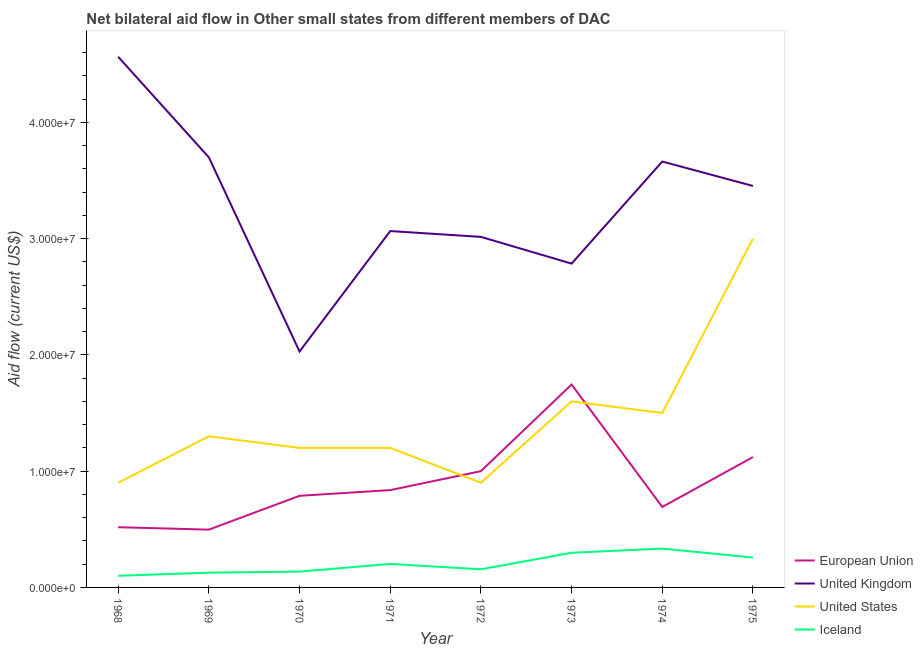How many different coloured lines are there?
Your answer should be very brief. 4. Is the number of lines equal to the number of legend labels?
Give a very brief answer. Yes. What is the amount of aid given by iceland in 1974?
Keep it short and to the point. 3.34e+06. Across all years, what is the maximum amount of aid given by uk?
Give a very brief answer. 4.56e+07. Across all years, what is the minimum amount of aid given by us?
Your answer should be very brief. 9.00e+06. In which year was the amount of aid given by us maximum?
Your response must be concise. 1975. In which year was the amount of aid given by us minimum?
Provide a succinct answer. 1968. What is the total amount of aid given by eu in the graph?
Provide a short and direct response. 7.20e+07. What is the difference between the amount of aid given by iceland in 1969 and that in 1971?
Provide a succinct answer. -7.50e+05. What is the difference between the amount of aid given by us in 1969 and the amount of aid given by uk in 1972?
Your answer should be very brief. -1.72e+07. What is the average amount of aid given by us per year?
Offer a terse response. 1.45e+07. In the year 1974, what is the difference between the amount of aid given by us and amount of aid given by uk?
Your answer should be compact. -2.16e+07. What is the ratio of the amount of aid given by uk in 1970 to that in 1972?
Provide a short and direct response. 0.67. Is the amount of aid given by us in 1970 less than that in 1972?
Provide a succinct answer. No. Is the difference between the amount of aid given by eu in 1970 and 1974 greater than the difference between the amount of aid given by us in 1970 and 1974?
Provide a short and direct response. Yes. What is the difference between the highest and the second highest amount of aid given by uk?
Give a very brief answer. 8.65e+06. What is the difference between the highest and the lowest amount of aid given by uk?
Your answer should be compact. 2.54e+07. Is it the case that in every year, the sum of the amount of aid given by eu and amount of aid given by uk is greater than the amount of aid given by us?
Your response must be concise. Yes. Is the amount of aid given by iceland strictly less than the amount of aid given by uk over the years?
Your answer should be compact. Yes. How many years are there in the graph?
Give a very brief answer. 8. What is the difference between two consecutive major ticks on the Y-axis?
Give a very brief answer. 1.00e+07. Are the values on the major ticks of Y-axis written in scientific E-notation?
Your response must be concise. Yes. Does the graph contain any zero values?
Keep it short and to the point. No. Where does the legend appear in the graph?
Your answer should be very brief. Bottom right. How many legend labels are there?
Offer a terse response. 4. What is the title of the graph?
Keep it short and to the point. Net bilateral aid flow in Other small states from different members of DAC. Does "Secondary general" appear as one of the legend labels in the graph?
Your response must be concise. No. What is the label or title of the X-axis?
Your response must be concise. Year. What is the label or title of the Y-axis?
Provide a succinct answer. Aid flow (current US$). What is the Aid flow (current US$) in European Union in 1968?
Your answer should be compact. 5.18e+06. What is the Aid flow (current US$) of United Kingdom in 1968?
Your response must be concise. 4.56e+07. What is the Aid flow (current US$) in United States in 1968?
Your answer should be very brief. 9.00e+06. What is the Aid flow (current US$) in Iceland in 1968?
Keep it short and to the point. 1.00e+06. What is the Aid flow (current US$) of European Union in 1969?
Offer a very short reply. 4.97e+06. What is the Aid flow (current US$) in United Kingdom in 1969?
Your response must be concise. 3.70e+07. What is the Aid flow (current US$) of United States in 1969?
Ensure brevity in your answer.  1.30e+07. What is the Aid flow (current US$) in Iceland in 1969?
Provide a succinct answer. 1.27e+06. What is the Aid flow (current US$) of European Union in 1970?
Offer a very short reply. 7.88e+06. What is the Aid flow (current US$) of United Kingdom in 1970?
Ensure brevity in your answer.  2.03e+07. What is the Aid flow (current US$) of United States in 1970?
Give a very brief answer. 1.20e+07. What is the Aid flow (current US$) in Iceland in 1970?
Provide a succinct answer. 1.36e+06. What is the Aid flow (current US$) of European Union in 1971?
Keep it short and to the point. 8.37e+06. What is the Aid flow (current US$) of United Kingdom in 1971?
Provide a short and direct response. 3.06e+07. What is the Aid flow (current US$) of Iceland in 1971?
Ensure brevity in your answer.  2.02e+06. What is the Aid flow (current US$) in United Kingdom in 1972?
Offer a very short reply. 3.02e+07. What is the Aid flow (current US$) in United States in 1972?
Your response must be concise. 9.00e+06. What is the Aid flow (current US$) of Iceland in 1972?
Provide a short and direct response. 1.56e+06. What is the Aid flow (current US$) of European Union in 1973?
Make the answer very short. 1.74e+07. What is the Aid flow (current US$) in United Kingdom in 1973?
Provide a short and direct response. 2.78e+07. What is the Aid flow (current US$) in United States in 1973?
Your answer should be very brief. 1.60e+07. What is the Aid flow (current US$) of Iceland in 1973?
Provide a succinct answer. 2.98e+06. What is the Aid flow (current US$) in European Union in 1974?
Give a very brief answer. 6.92e+06. What is the Aid flow (current US$) in United Kingdom in 1974?
Provide a short and direct response. 3.66e+07. What is the Aid flow (current US$) in United States in 1974?
Offer a terse response. 1.50e+07. What is the Aid flow (current US$) of Iceland in 1974?
Provide a succinct answer. 3.34e+06. What is the Aid flow (current US$) of European Union in 1975?
Your response must be concise. 1.12e+07. What is the Aid flow (current US$) in United Kingdom in 1975?
Your answer should be compact. 3.45e+07. What is the Aid flow (current US$) in United States in 1975?
Offer a very short reply. 3.00e+07. What is the Aid flow (current US$) in Iceland in 1975?
Your answer should be compact. 2.57e+06. Across all years, what is the maximum Aid flow (current US$) in European Union?
Your answer should be very brief. 1.74e+07. Across all years, what is the maximum Aid flow (current US$) of United Kingdom?
Offer a very short reply. 4.56e+07. Across all years, what is the maximum Aid flow (current US$) of United States?
Provide a succinct answer. 3.00e+07. Across all years, what is the maximum Aid flow (current US$) of Iceland?
Provide a succinct answer. 3.34e+06. Across all years, what is the minimum Aid flow (current US$) in European Union?
Your response must be concise. 4.97e+06. Across all years, what is the minimum Aid flow (current US$) in United Kingdom?
Your answer should be very brief. 2.03e+07. Across all years, what is the minimum Aid flow (current US$) in United States?
Provide a succinct answer. 9.00e+06. Across all years, what is the minimum Aid flow (current US$) of Iceland?
Ensure brevity in your answer.  1.00e+06. What is the total Aid flow (current US$) of European Union in the graph?
Ensure brevity in your answer.  7.20e+07. What is the total Aid flow (current US$) in United Kingdom in the graph?
Ensure brevity in your answer.  2.63e+08. What is the total Aid flow (current US$) of United States in the graph?
Your answer should be compact. 1.16e+08. What is the total Aid flow (current US$) of Iceland in the graph?
Provide a short and direct response. 1.61e+07. What is the difference between the Aid flow (current US$) of United Kingdom in 1968 and that in 1969?
Make the answer very short. 8.65e+06. What is the difference between the Aid flow (current US$) of United States in 1968 and that in 1969?
Provide a succinct answer. -4.00e+06. What is the difference between the Aid flow (current US$) of Iceland in 1968 and that in 1969?
Give a very brief answer. -2.70e+05. What is the difference between the Aid flow (current US$) of European Union in 1968 and that in 1970?
Keep it short and to the point. -2.70e+06. What is the difference between the Aid flow (current US$) in United Kingdom in 1968 and that in 1970?
Keep it short and to the point. 2.54e+07. What is the difference between the Aid flow (current US$) of Iceland in 1968 and that in 1970?
Your response must be concise. -3.60e+05. What is the difference between the Aid flow (current US$) of European Union in 1968 and that in 1971?
Keep it short and to the point. -3.19e+06. What is the difference between the Aid flow (current US$) of United Kingdom in 1968 and that in 1971?
Your response must be concise. 1.50e+07. What is the difference between the Aid flow (current US$) in United States in 1968 and that in 1971?
Your answer should be compact. -3.00e+06. What is the difference between the Aid flow (current US$) in Iceland in 1968 and that in 1971?
Provide a short and direct response. -1.02e+06. What is the difference between the Aid flow (current US$) in European Union in 1968 and that in 1972?
Provide a short and direct response. -4.82e+06. What is the difference between the Aid flow (current US$) in United Kingdom in 1968 and that in 1972?
Ensure brevity in your answer.  1.55e+07. What is the difference between the Aid flow (current US$) of United States in 1968 and that in 1972?
Provide a short and direct response. 0. What is the difference between the Aid flow (current US$) in Iceland in 1968 and that in 1972?
Your answer should be compact. -5.60e+05. What is the difference between the Aid flow (current US$) of European Union in 1968 and that in 1973?
Give a very brief answer. -1.23e+07. What is the difference between the Aid flow (current US$) of United Kingdom in 1968 and that in 1973?
Your response must be concise. 1.78e+07. What is the difference between the Aid flow (current US$) of United States in 1968 and that in 1973?
Keep it short and to the point. -7.00e+06. What is the difference between the Aid flow (current US$) in Iceland in 1968 and that in 1973?
Offer a terse response. -1.98e+06. What is the difference between the Aid flow (current US$) in European Union in 1968 and that in 1974?
Offer a terse response. -1.74e+06. What is the difference between the Aid flow (current US$) of United Kingdom in 1968 and that in 1974?
Provide a short and direct response. 9.01e+06. What is the difference between the Aid flow (current US$) of United States in 1968 and that in 1974?
Your answer should be compact. -6.00e+06. What is the difference between the Aid flow (current US$) of Iceland in 1968 and that in 1974?
Give a very brief answer. -2.34e+06. What is the difference between the Aid flow (current US$) of European Union in 1968 and that in 1975?
Make the answer very short. -6.03e+06. What is the difference between the Aid flow (current US$) of United Kingdom in 1968 and that in 1975?
Offer a very short reply. 1.11e+07. What is the difference between the Aid flow (current US$) of United States in 1968 and that in 1975?
Ensure brevity in your answer.  -2.10e+07. What is the difference between the Aid flow (current US$) of Iceland in 1968 and that in 1975?
Make the answer very short. -1.57e+06. What is the difference between the Aid flow (current US$) in European Union in 1969 and that in 1970?
Your answer should be compact. -2.91e+06. What is the difference between the Aid flow (current US$) of United Kingdom in 1969 and that in 1970?
Ensure brevity in your answer.  1.67e+07. What is the difference between the Aid flow (current US$) in United States in 1969 and that in 1970?
Offer a very short reply. 1.00e+06. What is the difference between the Aid flow (current US$) of Iceland in 1969 and that in 1970?
Your answer should be compact. -9.00e+04. What is the difference between the Aid flow (current US$) in European Union in 1969 and that in 1971?
Make the answer very short. -3.40e+06. What is the difference between the Aid flow (current US$) of United Kingdom in 1969 and that in 1971?
Your response must be concise. 6.34e+06. What is the difference between the Aid flow (current US$) in United States in 1969 and that in 1971?
Your response must be concise. 1.00e+06. What is the difference between the Aid flow (current US$) of Iceland in 1969 and that in 1971?
Offer a very short reply. -7.50e+05. What is the difference between the Aid flow (current US$) in European Union in 1969 and that in 1972?
Provide a succinct answer. -5.03e+06. What is the difference between the Aid flow (current US$) in United Kingdom in 1969 and that in 1972?
Ensure brevity in your answer.  6.84e+06. What is the difference between the Aid flow (current US$) in European Union in 1969 and that in 1973?
Your answer should be very brief. -1.25e+07. What is the difference between the Aid flow (current US$) of United Kingdom in 1969 and that in 1973?
Provide a short and direct response. 9.14e+06. What is the difference between the Aid flow (current US$) in United States in 1969 and that in 1973?
Your answer should be compact. -3.00e+06. What is the difference between the Aid flow (current US$) of Iceland in 1969 and that in 1973?
Provide a short and direct response. -1.71e+06. What is the difference between the Aid flow (current US$) of European Union in 1969 and that in 1974?
Your answer should be very brief. -1.95e+06. What is the difference between the Aid flow (current US$) in United States in 1969 and that in 1974?
Offer a very short reply. -2.00e+06. What is the difference between the Aid flow (current US$) in Iceland in 1969 and that in 1974?
Give a very brief answer. -2.07e+06. What is the difference between the Aid flow (current US$) in European Union in 1969 and that in 1975?
Provide a short and direct response. -6.24e+06. What is the difference between the Aid flow (current US$) in United Kingdom in 1969 and that in 1975?
Offer a very short reply. 2.46e+06. What is the difference between the Aid flow (current US$) in United States in 1969 and that in 1975?
Offer a very short reply. -1.70e+07. What is the difference between the Aid flow (current US$) in Iceland in 1969 and that in 1975?
Ensure brevity in your answer.  -1.30e+06. What is the difference between the Aid flow (current US$) in European Union in 1970 and that in 1971?
Your response must be concise. -4.90e+05. What is the difference between the Aid flow (current US$) of United Kingdom in 1970 and that in 1971?
Keep it short and to the point. -1.04e+07. What is the difference between the Aid flow (current US$) of Iceland in 1970 and that in 1971?
Provide a succinct answer. -6.60e+05. What is the difference between the Aid flow (current US$) of European Union in 1970 and that in 1972?
Give a very brief answer. -2.12e+06. What is the difference between the Aid flow (current US$) in United Kingdom in 1970 and that in 1972?
Ensure brevity in your answer.  -9.86e+06. What is the difference between the Aid flow (current US$) in United States in 1970 and that in 1972?
Your answer should be compact. 3.00e+06. What is the difference between the Aid flow (current US$) of European Union in 1970 and that in 1973?
Provide a succinct answer. -9.57e+06. What is the difference between the Aid flow (current US$) in United Kingdom in 1970 and that in 1973?
Your answer should be very brief. -7.56e+06. What is the difference between the Aid flow (current US$) in United States in 1970 and that in 1973?
Provide a succinct answer. -4.00e+06. What is the difference between the Aid flow (current US$) in Iceland in 1970 and that in 1973?
Give a very brief answer. -1.62e+06. What is the difference between the Aid flow (current US$) of European Union in 1970 and that in 1974?
Keep it short and to the point. 9.60e+05. What is the difference between the Aid flow (current US$) of United Kingdom in 1970 and that in 1974?
Give a very brief answer. -1.63e+07. What is the difference between the Aid flow (current US$) in Iceland in 1970 and that in 1974?
Your response must be concise. -1.98e+06. What is the difference between the Aid flow (current US$) of European Union in 1970 and that in 1975?
Ensure brevity in your answer.  -3.33e+06. What is the difference between the Aid flow (current US$) of United Kingdom in 1970 and that in 1975?
Make the answer very short. -1.42e+07. What is the difference between the Aid flow (current US$) in United States in 1970 and that in 1975?
Your answer should be compact. -1.80e+07. What is the difference between the Aid flow (current US$) in Iceland in 1970 and that in 1975?
Give a very brief answer. -1.21e+06. What is the difference between the Aid flow (current US$) of European Union in 1971 and that in 1972?
Keep it short and to the point. -1.63e+06. What is the difference between the Aid flow (current US$) of United States in 1971 and that in 1972?
Your answer should be very brief. 3.00e+06. What is the difference between the Aid flow (current US$) of Iceland in 1971 and that in 1972?
Give a very brief answer. 4.60e+05. What is the difference between the Aid flow (current US$) in European Union in 1971 and that in 1973?
Keep it short and to the point. -9.08e+06. What is the difference between the Aid flow (current US$) of United Kingdom in 1971 and that in 1973?
Ensure brevity in your answer.  2.80e+06. What is the difference between the Aid flow (current US$) of United States in 1971 and that in 1973?
Your response must be concise. -4.00e+06. What is the difference between the Aid flow (current US$) of Iceland in 1971 and that in 1973?
Your response must be concise. -9.60e+05. What is the difference between the Aid flow (current US$) in European Union in 1971 and that in 1974?
Give a very brief answer. 1.45e+06. What is the difference between the Aid flow (current US$) of United Kingdom in 1971 and that in 1974?
Your answer should be very brief. -5.98e+06. What is the difference between the Aid flow (current US$) in United States in 1971 and that in 1974?
Your response must be concise. -3.00e+06. What is the difference between the Aid flow (current US$) in Iceland in 1971 and that in 1974?
Your answer should be very brief. -1.32e+06. What is the difference between the Aid flow (current US$) of European Union in 1971 and that in 1975?
Keep it short and to the point. -2.84e+06. What is the difference between the Aid flow (current US$) of United Kingdom in 1971 and that in 1975?
Give a very brief answer. -3.88e+06. What is the difference between the Aid flow (current US$) of United States in 1971 and that in 1975?
Ensure brevity in your answer.  -1.80e+07. What is the difference between the Aid flow (current US$) of Iceland in 1971 and that in 1975?
Make the answer very short. -5.50e+05. What is the difference between the Aid flow (current US$) of European Union in 1972 and that in 1973?
Offer a terse response. -7.45e+06. What is the difference between the Aid flow (current US$) of United Kingdom in 1972 and that in 1973?
Provide a succinct answer. 2.30e+06. What is the difference between the Aid flow (current US$) of United States in 1972 and that in 1973?
Make the answer very short. -7.00e+06. What is the difference between the Aid flow (current US$) in Iceland in 1972 and that in 1973?
Provide a succinct answer. -1.42e+06. What is the difference between the Aid flow (current US$) in European Union in 1972 and that in 1974?
Provide a short and direct response. 3.08e+06. What is the difference between the Aid flow (current US$) of United Kingdom in 1972 and that in 1974?
Offer a very short reply. -6.48e+06. What is the difference between the Aid flow (current US$) of United States in 1972 and that in 1974?
Your response must be concise. -6.00e+06. What is the difference between the Aid flow (current US$) of Iceland in 1972 and that in 1974?
Give a very brief answer. -1.78e+06. What is the difference between the Aid flow (current US$) in European Union in 1972 and that in 1975?
Your response must be concise. -1.21e+06. What is the difference between the Aid flow (current US$) of United Kingdom in 1972 and that in 1975?
Ensure brevity in your answer.  -4.38e+06. What is the difference between the Aid flow (current US$) of United States in 1972 and that in 1975?
Your answer should be very brief. -2.10e+07. What is the difference between the Aid flow (current US$) of Iceland in 1972 and that in 1975?
Offer a terse response. -1.01e+06. What is the difference between the Aid flow (current US$) of European Union in 1973 and that in 1974?
Provide a short and direct response. 1.05e+07. What is the difference between the Aid flow (current US$) in United Kingdom in 1973 and that in 1974?
Make the answer very short. -8.78e+06. What is the difference between the Aid flow (current US$) of United States in 1973 and that in 1974?
Keep it short and to the point. 1.00e+06. What is the difference between the Aid flow (current US$) in Iceland in 1973 and that in 1974?
Your answer should be very brief. -3.60e+05. What is the difference between the Aid flow (current US$) of European Union in 1973 and that in 1975?
Your response must be concise. 6.24e+06. What is the difference between the Aid flow (current US$) in United Kingdom in 1973 and that in 1975?
Your answer should be very brief. -6.68e+06. What is the difference between the Aid flow (current US$) in United States in 1973 and that in 1975?
Ensure brevity in your answer.  -1.40e+07. What is the difference between the Aid flow (current US$) of Iceland in 1973 and that in 1975?
Provide a succinct answer. 4.10e+05. What is the difference between the Aid flow (current US$) of European Union in 1974 and that in 1975?
Your response must be concise. -4.29e+06. What is the difference between the Aid flow (current US$) of United Kingdom in 1974 and that in 1975?
Offer a terse response. 2.10e+06. What is the difference between the Aid flow (current US$) in United States in 1974 and that in 1975?
Your answer should be compact. -1.50e+07. What is the difference between the Aid flow (current US$) in Iceland in 1974 and that in 1975?
Your answer should be compact. 7.70e+05. What is the difference between the Aid flow (current US$) of European Union in 1968 and the Aid flow (current US$) of United Kingdom in 1969?
Your answer should be compact. -3.18e+07. What is the difference between the Aid flow (current US$) of European Union in 1968 and the Aid flow (current US$) of United States in 1969?
Provide a short and direct response. -7.82e+06. What is the difference between the Aid flow (current US$) of European Union in 1968 and the Aid flow (current US$) of Iceland in 1969?
Provide a short and direct response. 3.91e+06. What is the difference between the Aid flow (current US$) of United Kingdom in 1968 and the Aid flow (current US$) of United States in 1969?
Offer a very short reply. 3.26e+07. What is the difference between the Aid flow (current US$) of United Kingdom in 1968 and the Aid flow (current US$) of Iceland in 1969?
Your answer should be compact. 4.44e+07. What is the difference between the Aid flow (current US$) of United States in 1968 and the Aid flow (current US$) of Iceland in 1969?
Provide a short and direct response. 7.73e+06. What is the difference between the Aid flow (current US$) in European Union in 1968 and the Aid flow (current US$) in United Kingdom in 1970?
Your answer should be compact. -1.51e+07. What is the difference between the Aid flow (current US$) in European Union in 1968 and the Aid flow (current US$) in United States in 1970?
Give a very brief answer. -6.82e+06. What is the difference between the Aid flow (current US$) of European Union in 1968 and the Aid flow (current US$) of Iceland in 1970?
Your response must be concise. 3.82e+06. What is the difference between the Aid flow (current US$) of United Kingdom in 1968 and the Aid flow (current US$) of United States in 1970?
Keep it short and to the point. 3.36e+07. What is the difference between the Aid flow (current US$) of United Kingdom in 1968 and the Aid flow (current US$) of Iceland in 1970?
Offer a very short reply. 4.43e+07. What is the difference between the Aid flow (current US$) in United States in 1968 and the Aid flow (current US$) in Iceland in 1970?
Your answer should be compact. 7.64e+06. What is the difference between the Aid flow (current US$) in European Union in 1968 and the Aid flow (current US$) in United Kingdom in 1971?
Keep it short and to the point. -2.55e+07. What is the difference between the Aid flow (current US$) of European Union in 1968 and the Aid flow (current US$) of United States in 1971?
Offer a very short reply. -6.82e+06. What is the difference between the Aid flow (current US$) in European Union in 1968 and the Aid flow (current US$) in Iceland in 1971?
Your response must be concise. 3.16e+06. What is the difference between the Aid flow (current US$) in United Kingdom in 1968 and the Aid flow (current US$) in United States in 1971?
Provide a succinct answer. 3.36e+07. What is the difference between the Aid flow (current US$) in United Kingdom in 1968 and the Aid flow (current US$) in Iceland in 1971?
Keep it short and to the point. 4.36e+07. What is the difference between the Aid flow (current US$) in United States in 1968 and the Aid flow (current US$) in Iceland in 1971?
Provide a succinct answer. 6.98e+06. What is the difference between the Aid flow (current US$) in European Union in 1968 and the Aid flow (current US$) in United Kingdom in 1972?
Your response must be concise. -2.50e+07. What is the difference between the Aid flow (current US$) of European Union in 1968 and the Aid flow (current US$) of United States in 1972?
Provide a succinct answer. -3.82e+06. What is the difference between the Aid flow (current US$) of European Union in 1968 and the Aid flow (current US$) of Iceland in 1972?
Offer a terse response. 3.62e+06. What is the difference between the Aid flow (current US$) of United Kingdom in 1968 and the Aid flow (current US$) of United States in 1972?
Give a very brief answer. 3.66e+07. What is the difference between the Aid flow (current US$) of United Kingdom in 1968 and the Aid flow (current US$) of Iceland in 1972?
Offer a very short reply. 4.41e+07. What is the difference between the Aid flow (current US$) of United States in 1968 and the Aid flow (current US$) of Iceland in 1972?
Provide a succinct answer. 7.44e+06. What is the difference between the Aid flow (current US$) of European Union in 1968 and the Aid flow (current US$) of United Kingdom in 1973?
Offer a terse response. -2.27e+07. What is the difference between the Aid flow (current US$) of European Union in 1968 and the Aid flow (current US$) of United States in 1973?
Offer a very short reply. -1.08e+07. What is the difference between the Aid flow (current US$) of European Union in 1968 and the Aid flow (current US$) of Iceland in 1973?
Offer a terse response. 2.20e+06. What is the difference between the Aid flow (current US$) of United Kingdom in 1968 and the Aid flow (current US$) of United States in 1973?
Your answer should be very brief. 2.96e+07. What is the difference between the Aid flow (current US$) of United Kingdom in 1968 and the Aid flow (current US$) of Iceland in 1973?
Provide a succinct answer. 4.27e+07. What is the difference between the Aid flow (current US$) in United States in 1968 and the Aid flow (current US$) in Iceland in 1973?
Make the answer very short. 6.02e+06. What is the difference between the Aid flow (current US$) of European Union in 1968 and the Aid flow (current US$) of United Kingdom in 1974?
Offer a terse response. -3.14e+07. What is the difference between the Aid flow (current US$) in European Union in 1968 and the Aid flow (current US$) in United States in 1974?
Provide a succinct answer. -9.82e+06. What is the difference between the Aid flow (current US$) of European Union in 1968 and the Aid flow (current US$) of Iceland in 1974?
Keep it short and to the point. 1.84e+06. What is the difference between the Aid flow (current US$) in United Kingdom in 1968 and the Aid flow (current US$) in United States in 1974?
Offer a terse response. 3.06e+07. What is the difference between the Aid flow (current US$) of United Kingdom in 1968 and the Aid flow (current US$) of Iceland in 1974?
Your response must be concise. 4.23e+07. What is the difference between the Aid flow (current US$) in United States in 1968 and the Aid flow (current US$) in Iceland in 1974?
Offer a terse response. 5.66e+06. What is the difference between the Aid flow (current US$) of European Union in 1968 and the Aid flow (current US$) of United Kingdom in 1975?
Offer a terse response. -2.94e+07. What is the difference between the Aid flow (current US$) in European Union in 1968 and the Aid flow (current US$) in United States in 1975?
Offer a very short reply. -2.48e+07. What is the difference between the Aid flow (current US$) in European Union in 1968 and the Aid flow (current US$) in Iceland in 1975?
Ensure brevity in your answer.  2.61e+06. What is the difference between the Aid flow (current US$) in United Kingdom in 1968 and the Aid flow (current US$) in United States in 1975?
Make the answer very short. 1.56e+07. What is the difference between the Aid flow (current US$) in United Kingdom in 1968 and the Aid flow (current US$) in Iceland in 1975?
Provide a short and direct response. 4.31e+07. What is the difference between the Aid flow (current US$) of United States in 1968 and the Aid flow (current US$) of Iceland in 1975?
Offer a terse response. 6.43e+06. What is the difference between the Aid flow (current US$) of European Union in 1969 and the Aid flow (current US$) of United Kingdom in 1970?
Make the answer very short. -1.53e+07. What is the difference between the Aid flow (current US$) in European Union in 1969 and the Aid flow (current US$) in United States in 1970?
Give a very brief answer. -7.03e+06. What is the difference between the Aid flow (current US$) of European Union in 1969 and the Aid flow (current US$) of Iceland in 1970?
Make the answer very short. 3.61e+06. What is the difference between the Aid flow (current US$) in United Kingdom in 1969 and the Aid flow (current US$) in United States in 1970?
Your answer should be compact. 2.50e+07. What is the difference between the Aid flow (current US$) of United Kingdom in 1969 and the Aid flow (current US$) of Iceland in 1970?
Your answer should be very brief. 3.56e+07. What is the difference between the Aid flow (current US$) in United States in 1969 and the Aid flow (current US$) in Iceland in 1970?
Offer a terse response. 1.16e+07. What is the difference between the Aid flow (current US$) of European Union in 1969 and the Aid flow (current US$) of United Kingdom in 1971?
Make the answer very short. -2.57e+07. What is the difference between the Aid flow (current US$) of European Union in 1969 and the Aid flow (current US$) of United States in 1971?
Your answer should be very brief. -7.03e+06. What is the difference between the Aid flow (current US$) in European Union in 1969 and the Aid flow (current US$) in Iceland in 1971?
Provide a succinct answer. 2.95e+06. What is the difference between the Aid flow (current US$) of United Kingdom in 1969 and the Aid flow (current US$) of United States in 1971?
Offer a terse response. 2.50e+07. What is the difference between the Aid flow (current US$) in United Kingdom in 1969 and the Aid flow (current US$) in Iceland in 1971?
Make the answer very short. 3.50e+07. What is the difference between the Aid flow (current US$) in United States in 1969 and the Aid flow (current US$) in Iceland in 1971?
Keep it short and to the point. 1.10e+07. What is the difference between the Aid flow (current US$) in European Union in 1969 and the Aid flow (current US$) in United Kingdom in 1972?
Offer a terse response. -2.52e+07. What is the difference between the Aid flow (current US$) of European Union in 1969 and the Aid flow (current US$) of United States in 1972?
Ensure brevity in your answer.  -4.03e+06. What is the difference between the Aid flow (current US$) of European Union in 1969 and the Aid flow (current US$) of Iceland in 1972?
Your answer should be very brief. 3.41e+06. What is the difference between the Aid flow (current US$) of United Kingdom in 1969 and the Aid flow (current US$) of United States in 1972?
Provide a succinct answer. 2.80e+07. What is the difference between the Aid flow (current US$) in United Kingdom in 1969 and the Aid flow (current US$) in Iceland in 1972?
Offer a terse response. 3.54e+07. What is the difference between the Aid flow (current US$) in United States in 1969 and the Aid flow (current US$) in Iceland in 1972?
Provide a short and direct response. 1.14e+07. What is the difference between the Aid flow (current US$) of European Union in 1969 and the Aid flow (current US$) of United Kingdom in 1973?
Give a very brief answer. -2.29e+07. What is the difference between the Aid flow (current US$) in European Union in 1969 and the Aid flow (current US$) in United States in 1973?
Give a very brief answer. -1.10e+07. What is the difference between the Aid flow (current US$) in European Union in 1969 and the Aid flow (current US$) in Iceland in 1973?
Ensure brevity in your answer.  1.99e+06. What is the difference between the Aid flow (current US$) of United Kingdom in 1969 and the Aid flow (current US$) of United States in 1973?
Provide a succinct answer. 2.10e+07. What is the difference between the Aid flow (current US$) in United Kingdom in 1969 and the Aid flow (current US$) in Iceland in 1973?
Provide a succinct answer. 3.40e+07. What is the difference between the Aid flow (current US$) of United States in 1969 and the Aid flow (current US$) of Iceland in 1973?
Offer a terse response. 1.00e+07. What is the difference between the Aid flow (current US$) of European Union in 1969 and the Aid flow (current US$) of United Kingdom in 1974?
Make the answer very short. -3.17e+07. What is the difference between the Aid flow (current US$) of European Union in 1969 and the Aid flow (current US$) of United States in 1974?
Give a very brief answer. -1.00e+07. What is the difference between the Aid flow (current US$) of European Union in 1969 and the Aid flow (current US$) of Iceland in 1974?
Your response must be concise. 1.63e+06. What is the difference between the Aid flow (current US$) of United Kingdom in 1969 and the Aid flow (current US$) of United States in 1974?
Your response must be concise. 2.20e+07. What is the difference between the Aid flow (current US$) in United Kingdom in 1969 and the Aid flow (current US$) in Iceland in 1974?
Offer a very short reply. 3.36e+07. What is the difference between the Aid flow (current US$) of United States in 1969 and the Aid flow (current US$) of Iceland in 1974?
Your answer should be very brief. 9.66e+06. What is the difference between the Aid flow (current US$) in European Union in 1969 and the Aid flow (current US$) in United Kingdom in 1975?
Your answer should be compact. -2.96e+07. What is the difference between the Aid flow (current US$) of European Union in 1969 and the Aid flow (current US$) of United States in 1975?
Keep it short and to the point. -2.50e+07. What is the difference between the Aid flow (current US$) in European Union in 1969 and the Aid flow (current US$) in Iceland in 1975?
Provide a succinct answer. 2.40e+06. What is the difference between the Aid flow (current US$) in United Kingdom in 1969 and the Aid flow (current US$) in United States in 1975?
Offer a terse response. 6.99e+06. What is the difference between the Aid flow (current US$) of United Kingdom in 1969 and the Aid flow (current US$) of Iceland in 1975?
Your answer should be compact. 3.44e+07. What is the difference between the Aid flow (current US$) of United States in 1969 and the Aid flow (current US$) of Iceland in 1975?
Your answer should be very brief. 1.04e+07. What is the difference between the Aid flow (current US$) of European Union in 1970 and the Aid flow (current US$) of United Kingdom in 1971?
Give a very brief answer. -2.28e+07. What is the difference between the Aid flow (current US$) in European Union in 1970 and the Aid flow (current US$) in United States in 1971?
Keep it short and to the point. -4.12e+06. What is the difference between the Aid flow (current US$) in European Union in 1970 and the Aid flow (current US$) in Iceland in 1971?
Your answer should be very brief. 5.86e+06. What is the difference between the Aid flow (current US$) of United Kingdom in 1970 and the Aid flow (current US$) of United States in 1971?
Offer a very short reply. 8.29e+06. What is the difference between the Aid flow (current US$) in United Kingdom in 1970 and the Aid flow (current US$) in Iceland in 1971?
Keep it short and to the point. 1.83e+07. What is the difference between the Aid flow (current US$) of United States in 1970 and the Aid flow (current US$) of Iceland in 1971?
Give a very brief answer. 9.98e+06. What is the difference between the Aid flow (current US$) of European Union in 1970 and the Aid flow (current US$) of United Kingdom in 1972?
Ensure brevity in your answer.  -2.23e+07. What is the difference between the Aid flow (current US$) of European Union in 1970 and the Aid flow (current US$) of United States in 1972?
Your answer should be compact. -1.12e+06. What is the difference between the Aid flow (current US$) in European Union in 1970 and the Aid flow (current US$) in Iceland in 1972?
Make the answer very short. 6.32e+06. What is the difference between the Aid flow (current US$) of United Kingdom in 1970 and the Aid flow (current US$) of United States in 1972?
Offer a very short reply. 1.13e+07. What is the difference between the Aid flow (current US$) of United Kingdom in 1970 and the Aid flow (current US$) of Iceland in 1972?
Your response must be concise. 1.87e+07. What is the difference between the Aid flow (current US$) of United States in 1970 and the Aid flow (current US$) of Iceland in 1972?
Your response must be concise. 1.04e+07. What is the difference between the Aid flow (current US$) of European Union in 1970 and the Aid flow (current US$) of United Kingdom in 1973?
Make the answer very short. -2.00e+07. What is the difference between the Aid flow (current US$) in European Union in 1970 and the Aid flow (current US$) in United States in 1973?
Your response must be concise. -8.12e+06. What is the difference between the Aid flow (current US$) of European Union in 1970 and the Aid flow (current US$) of Iceland in 1973?
Your answer should be compact. 4.90e+06. What is the difference between the Aid flow (current US$) of United Kingdom in 1970 and the Aid flow (current US$) of United States in 1973?
Make the answer very short. 4.29e+06. What is the difference between the Aid flow (current US$) of United Kingdom in 1970 and the Aid flow (current US$) of Iceland in 1973?
Make the answer very short. 1.73e+07. What is the difference between the Aid flow (current US$) of United States in 1970 and the Aid flow (current US$) of Iceland in 1973?
Give a very brief answer. 9.02e+06. What is the difference between the Aid flow (current US$) in European Union in 1970 and the Aid flow (current US$) in United Kingdom in 1974?
Your answer should be compact. -2.88e+07. What is the difference between the Aid flow (current US$) in European Union in 1970 and the Aid flow (current US$) in United States in 1974?
Your response must be concise. -7.12e+06. What is the difference between the Aid flow (current US$) in European Union in 1970 and the Aid flow (current US$) in Iceland in 1974?
Your answer should be compact. 4.54e+06. What is the difference between the Aid flow (current US$) of United Kingdom in 1970 and the Aid flow (current US$) of United States in 1974?
Your answer should be very brief. 5.29e+06. What is the difference between the Aid flow (current US$) in United Kingdom in 1970 and the Aid flow (current US$) in Iceland in 1974?
Provide a succinct answer. 1.70e+07. What is the difference between the Aid flow (current US$) of United States in 1970 and the Aid flow (current US$) of Iceland in 1974?
Your answer should be compact. 8.66e+06. What is the difference between the Aid flow (current US$) in European Union in 1970 and the Aid flow (current US$) in United Kingdom in 1975?
Provide a short and direct response. -2.66e+07. What is the difference between the Aid flow (current US$) of European Union in 1970 and the Aid flow (current US$) of United States in 1975?
Your answer should be compact. -2.21e+07. What is the difference between the Aid flow (current US$) in European Union in 1970 and the Aid flow (current US$) in Iceland in 1975?
Your response must be concise. 5.31e+06. What is the difference between the Aid flow (current US$) of United Kingdom in 1970 and the Aid flow (current US$) of United States in 1975?
Give a very brief answer. -9.71e+06. What is the difference between the Aid flow (current US$) in United Kingdom in 1970 and the Aid flow (current US$) in Iceland in 1975?
Your answer should be compact. 1.77e+07. What is the difference between the Aid flow (current US$) in United States in 1970 and the Aid flow (current US$) in Iceland in 1975?
Make the answer very short. 9.43e+06. What is the difference between the Aid flow (current US$) in European Union in 1971 and the Aid flow (current US$) in United Kingdom in 1972?
Provide a succinct answer. -2.18e+07. What is the difference between the Aid flow (current US$) of European Union in 1971 and the Aid flow (current US$) of United States in 1972?
Make the answer very short. -6.30e+05. What is the difference between the Aid flow (current US$) of European Union in 1971 and the Aid flow (current US$) of Iceland in 1972?
Make the answer very short. 6.81e+06. What is the difference between the Aid flow (current US$) in United Kingdom in 1971 and the Aid flow (current US$) in United States in 1972?
Ensure brevity in your answer.  2.16e+07. What is the difference between the Aid flow (current US$) in United Kingdom in 1971 and the Aid flow (current US$) in Iceland in 1972?
Give a very brief answer. 2.91e+07. What is the difference between the Aid flow (current US$) in United States in 1971 and the Aid flow (current US$) in Iceland in 1972?
Your response must be concise. 1.04e+07. What is the difference between the Aid flow (current US$) of European Union in 1971 and the Aid flow (current US$) of United Kingdom in 1973?
Your answer should be compact. -1.95e+07. What is the difference between the Aid flow (current US$) in European Union in 1971 and the Aid flow (current US$) in United States in 1973?
Your answer should be very brief. -7.63e+06. What is the difference between the Aid flow (current US$) in European Union in 1971 and the Aid flow (current US$) in Iceland in 1973?
Offer a very short reply. 5.39e+06. What is the difference between the Aid flow (current US$) in United Kingdom in 1971 and the Aid flow (current US$) in United States in 1973?
Your answer should be very brief. 1.46e+07. What is the difference between the Aid flow (current US$) in United Kingdom in 1971 and the Aid flow (current US$) in Iceland in 1973?
Your answer should be very brief. 2.77e+07. What is the difference between the Aid flow (current US$) in United States in 1971 and the Aid flow (current US$) in Iceland in 1973?
Your answer should be compact. 9.02e+06. What is the difference between the Aid flow (current US$) of European Union in 1971 and the Aid flow (current US$) of United Kingdom in 1974?
Provide a short and direct response. -2.83e+07. What is the difference between the Aid flow (current US$) of European Union in 1971 and the Aid flow (current US$) of United States in 1974?
Make the answer very short. -6.63e+06. What is the difference between the Aid flow (current US$) in European Union in 1971 and the Aid flow (current US$) in Iceland in 1974?
Make the answer very short. 5.03e+06. What is the difference between the Aid flow (current US$) in United Kingdom in 1971 and the Aid flow (current US$) in United States in 1974?
Keep it short and to the point. 1.56e+07. What is the difference between the Aid flow (current US$) in United Kingdom in 1971 and the Aid flow (current US$) in Iceland in 1974?
Give a very brief answer. 2.73e+07. What is the difference between the Aid flow (current US$) of United States in 1971 and the Aid flow (current US$) of Iceland in 1974?
Offer a very short reply. 8.66e+06. What is the difference between the Aid flow (current US$) in European Union in 1971 and the Aid flow (current US$) in United Kingdom in 1975?
Offer a terse response. -2.62e+07. What is the difference between the Aid flow (current US$) of European Union in 1971 and the Aid flow (current US$) of United States in 1975?
Your response must be concise. -2.16e+07. What is the difference between the Aid flow (current US$) in European Union in 1971 and the Aid flow (current US$) in Iceland in 1975?
Your answer should be compact. 5.80e+06. What is the difference between the Aid flow (current US$) in United Kingdom in 1971 and the Aid flow (current US$) in United States in 1975?
Your response must be concise. 6.50e+05. What is the difference between the Aid flow (current US$) in United Kingdom in 1971 and the Aid flow (current US$) in Iceland in 1975?
Keep it short and to the point. 2.81e+07. What is the difference between the Aid flow (current US$) of United States in 1971 and the Aid flow (current US$) of Iceland in 1975?
Your response must be concise. 9.43e+06. What is the difference between the Aid flow (current US$) of European Union in 1972 and the Aid flow (current US$) of United Kingdom in 1973?
Your answer should be very brief. -1.78e+07. What is the difference between the Aid flow (current US$) in European Union in 1972 and the Aid flow (current US$) in United States in 1973?
Provide a short and direct response. -6.00e+06. What is the difference between the Aid flow (current US$) in European Union in 1972 and the Aid flow (current US$) in Iceland in 1973?
Keep it short and to the point. 7.02e+06. What is the difference between the Aid flow (current US$) of United Kingdom in 1972 and the Aid flow (current US$) of United States in 1973?
Your answer should be very brief. 1.42e+07. What is the difference between the Aid flow (current US$) in United Kingdom in 1972 and the Aid flow (current US$) in Iceland in 1973?
Your answer should be compact. 2.72e+07. What is the difference between the Aid flow (current US$) in United States in 1972 and the Aid flow (current US$) in Iceland in 1973?
Provide a succinct answer. 6.02e+06. What is the difference between the Aid flow (current US$) in European Union in 1972 and the Aid flow (current US$) in United Kingdom in 1974?
Give a very brief answer. -2.66e+07. What is the difference between the Aid flow (current US$) in European Union in 1972 and the Aid flow (current US$) in United States in 1974?
Offer a very short reply. -5.00e+06. What is the difference between the Aid flow (current US$) of European Union in 1972 and the Aid flow (current US$) of Iceland in 1974?
Provide a succinct answer. 6.66e+06. What is the difference between the Aid flow (current US$) in United Kingdom in 1972 and the Aid flow (current US$) in United States in 1974?
Provide a short and direct response. 1.52e+07. What is the difference between the Aid flow (current US$) of United Kingdom in 1972 and the Aid flow (current US$) of Iceland in 1974?
Provide a succinct answer. 2.68e+07. What is the difference between the Aid flow (current US$) in United States in 1972 and the Aid flow (current US$) in Iceland in 1974?
Make the answer very short. 5.66e+06. What is the difference between the Aid flow (current US$) of European Union in 1972 and the Aid flow (current US$) of United Kingdom in 1975?
Provide a succinct answer. -2.45e+07. What is the difference between the Aid flow (current US$) in European Union in 1972 and the Aid flow (current US$) in United States in 1975?
Offer a terse response. -2.00e+07. What is the difference between the Aid flow (current US$) in European Union in 1972 and the Aid flow (current US$) in Iceland in 1975?
Give a very brief answer. 7.43e+06. What is the difference between the Aid flow (current US$) in United Kingdom in 1972 and the Aid flow (current US$) in Iceland in 1975?
Keep it short and to the point. 2.76e+07. What is the difference between the Aid flow (current US$) of United States in 1972 and the Aid flow (current US$) of Iceland in 1975?
Provide a succinct answer. 6.43e+06. What is the difference between the Aid flow (current US$) in European Union in 1973 and the Aid flow (current US$) in United Kingdom in 1974?
Your answer should be compact. -1.92e+07. What is the difference between the Aid flow (current US$) of European Union in 1973 and the Aid flow (current US$) of United States in 1974?
Offer a very short reply. 2.45e+06. What is the difference between the Aid flow (current US$) of European Union in 1973 and the Aid flow (current US$) of Iceland in 1974?
Keep it short and to the point. 1.41e+07. What is the difference between the Aid flow (current US$) in United Kingdom in 1973 and the Aid flow (current US$) in United States in 1974?
Keep it short and to the point. 1.28e+07. What is the difference between the Aid flow (current US$) of United Kingdom in 1973 and the Aid flow (current US$) of Iceland in 1974?
Give a very brief answer. 2.45e+07. What is the difference between the Aid flow (current US$) in United States in 1973 and the Aid flow (current US$) in Iceland in 1974?
Your answer should be compact. 1.27e+07. What is the difference between the Aid flow (current US$) of European Union in 1973 and the Aid flow (current US$) of United Kingdom in 1975?
Your response must be concise. -1.71e+07. What is the difference between the Aid flow (current US$) in European Union in 1973 and the Aid flow (current US$) in United States in 1975?
Offer a terse response. -1.26e+07. What is the difference between the Aid flow (current US$) of European Union in 1973 and the Aid flow (current US$) of Iceland in 1975?
Give a very brief answer. 1.49e+07. What is the difference between the Aid flow (current US$) of United Kingdom in 1973 and the Aid flow (current US$) of United States in 1975?
Make the answer very short. -2.15e+06. What is the difference between the Aid flow (current US$) in United Kingdom in 1973 and the Aid flow (current US$) in Iceland in 1975?
Your response must be concise. 2.53e+07. What is the difference between the Aid flow (current US$) of United States in 1973 and the Aid flow (current US$) of Iceland in 1975?
Ensure brevity in your answer.  1.34e+07. What is the difference between the Aid flow (current US$) in European Union in 1974 and the Aid flow (current US$) in United Kingdom in 1975?
Offer a terse response. -2.76e+07. What is the difference between the Aid flow (current US$) in European Union in 1974 and the Aid flow (current US$) in United States in 1975?
Your answer should be compact. -2.31e+07. What is the difference between the Aid flow (current US$) in European Union in 1974 and the Aid flow (current US$) in Iceland in 1975?
Provide a succinct answer. 4.35e+06. What is the difference between the Aid flow (current US$) of United Kingdom in 1974 and the Aid flow (current US$) of United States in 1975?
Your answer should be very brief. 6.63e+06. What is the difference between the Aid flow (current US$) of United Kingdom in 1974 and the Aid flow (current US$) of Iceland in 1975?
Your response must be concise. 3.41e+07. What is the difference between the Aid flow (current US$) in United States in 1974 and the Aid flow (current US$) in Iceland in 1975?
Make the answer very short. 1.24e+07. What is the average Aid flow (current US$) of European Union per year?
Ensure brevity in your answer.  9.00e+06. What is the average Aid flow (current US$) in United Kingdom per year?
Provide a succinct answer. 3.28e+07. What is the average Aid flow (current US$) in United States per year?
Provide a succinct answer. 1.45e+07. What is the average Aid flow (current US$) of Iceland per year?
Your answer should be very brief. 2.01e+06. In the year 1968, what is the difference between the Aid flow (current US$) of European Union and Aid flow (current US$) of United Kingdom?
Provide a short and direct response. -4.05e+07. In the year 1968, what is the difference between the Aid flow (current US$) in European Union and Aid flow (current US$) in United States?
Keep it short and to the point. -3.82e+06. In the year 1968, what is the difference between the Aid flow (current US$) of European Union and Aid flow (current US$) of Iceland?
Keep it short and to the point. 4.18e+06. In the year 1968, what is the difference between the Aid flow (current US$) in United Kingdom and Aid flow (current US$) in United States?
Keep it short and to the point. 3.66e+07. In the year 1968, what is the difference between the Aid flow (current US$) of United Kingdom and Aid flow (current US$) of Iceland?
Your answer should be very brief. 4.46e+07. In the year 1968, what is the difference between the Aid flow (current US$) in United States and Aid flow (current US$) in Iceland?
Your answer should be very brief. 8.00e+06. In the year 1969, what is the difference between the Aid flow (current US$) of European Union and Aid flow (current US$) of United Kingdom?
Your answer should be very brief. -3.20e+07. In the year 1969, what is the difference between the Aid flow (current US$) in European Union and Aid flow (current US$) in United States?
Offer a very short reply. -8.03e+06. In the year 1969, what is the difference between the Aid flow (current US$) of European Union and Aid flow (current US$) of Iceland?
Provide a succinct answer. 3.70e+06. In the year 1969, what is the difference between the Aid flow (current US$) of United Kingdom and Aid flow (current US$) of United States?
Provide a short and direct response. 2.40e+07. In the year 1969, what is the difference between the Aid flow (current US$) of United Kingdom and Aid flow (current US$) of Iceland?
Offer a very short reply. 3.57e+07. In the year 1969, what is the difference between the Aid flow (current US$) in United States and Aid flow (current US$) in Iceland?
Make the answer very short. 1.17e+07. In the year 1970, what is the difference between the Aid flow (current US$) of European Union and Aid flow (current US$) of United Kingdom?
Provide a succinct answer. -1.24e+07. In the year 1970, what is the difference between the Aid flow (current US$) in European Union and Aid flow (current US$) in United States?
Keep it short and to the point. -4.12e+06. In the year 1970, what is the difference between the Aid flow (current US$) in European Union and Aid flow (current US$) in Iceland?
Ensure brevity in your answer.  6.52e+06. In the year 1970, what is the difference between the Aid flow (current US$) of United Kingdom and Aid flow (current US$) of United States?
Offer a very short reply. 8.29e+06. In the year 1970, what is the difference between the Aid flow (current US$) of United Kingdom and Aid flow (current US$) of Iceland?
Make the answer very short. 1.89e+07. In the year 1970, what is the difference between the Aid flow (current US$) in United States and Aid flow (current US$) in Iceland?
Keep it short and to the point. 1.06e+07. In the year 1971, what is the difference between the Aid flow (current US$) in European Union and Aid flow (current US$) in United Kingdom?
Your response must be concise. -2.23e+07. In the year 1971, what is the difference between the Aid flow (current US$) in European Union and Aid flow (current US$) in United States?
Your answer should be very brief. -3.63e+06. In the year 1971, what is the difference between the Aid flow (current US$) of European Union and Aid flow (current US$) of Iceland?
Offer a very short reply. 6.35e+06. In the year 1971, what is the difference between the Aid flow (current US$) in United Kingdom and Aid flow (current US$) in United States?
Give a very brief answer. 1.86e+07. In the year 1971, what is the difference between the Aid flow (current US$) of United Kingdom and Aid flow (current US$) of Iceland?
Keep it short and to the point. 2.86e+07. In the year 1971, what is the difference between the Aid flow (current US$) of United States and Aid flow (current US$) of Iceland?
Keep it short and to the point. 9.98e+06. In the year 1972, what is the difference between the Aid flow (current US$) of European Union and Aid flow (current US$) of United Kingdom?
Offer a terse response. -2.02e+07. In the year 1972, what is the difference between the Aid flow (current US$) in European Union and Aid flow (current US$) in Iceland?
Offer a very short reply. 8.44e+06. In the year 1972, what is the difference between the Aid flow (current US$) in United Kingdom and Aid flow (current US$) in United States?
Provide a succinct answer. 2.12e+07. In the year 1972, what is the difference between the Aid flow (current US$) in United Kingdom and Aid flow (current US$) in Iceland?
Give a very brief answer. 2.86e+07. In the year 1972, what is the difference between the Aid flow (current US$) in United States and Aid flow (current US$) in Iceland?
Provide a succinct answer. 7.44e+06. In the year 1973, what is the difference between the Aid flow (current US$) in European Union and Aid flow (current US$) in United Kingdom?
Offer a terse response. -1.04e+07. In the year 1973, what is the difference between the Aid flow (current US$) in European Union and Aid flow (current US$) in United States?
Make the answer very short. 1.45e+06. In the year 1973, what is the difference between the Aid flow (current US$) in European Union and Aid flow (current US$) in Iceland?
Your answer should be very brief. 1.45e+07. In the year 1973, what is the difference between the Aid flow (current US$) in United Kingdom and Aid flow (current US$) in United States?
Offer a terse response. 1.18e+07. In the year 1973, what is the difference between the Aid flow (current US$) of United Kingdom and Aid flow (current US$) of Iceland?
Offer a terse response. 2.49e+07. In the year 1973, what is the difference between the Aid flow (current US$) of United States and Aid flow (current US$) of Iceland?
Ensure brevity in your answer.  1.30e+07. In the year 1974, what is the difference between the Aid flow (current US$) of European Union and Aid flow (current US$) of United Kingdom?
Your response must be concise. -2.97e+07. In the year 1974, what is the difference between the Aid flow (current US$) of European Union and Aid flow (current US$) of United States?
Make the answer very short. -8.08e+06. In the year 1974, what is the difference between the Aid flow (current US$) in European Union and Aid flow (current US$) in Iceland?
Provide a short and direct response. 3.58e+06. In the year 1974, what is the difference between the Aid flow (current US$) of United Kingdom and Aid flow (current US$) of United States?
Offer a terse response. 2.16e+07. In the year 1974, what is the difference between the Aid flow (current US$) of United Kingdom and Aid flow (current US$) of Iceland?
Provide a short and direct response. 3.33e+07. In the year 1974, what is the difference between the Aid flow (current US$) of United States and Aid flow (current US$) of Iceland?
Provide a short and direct response. 1.17e+07. In the year 1975, what is the difference between the Aid flow (current US$) in European Union and Aid flow (current US$) in United Kingdom?
Give a very brief answer. -2.33e+07. In the year 1975, what is the difference between the Aid flow (current US$) of European Union and Aid flow (current US$) of United States?
Provide a succinct answer. -1.88e+07. In the year 1975, what is the difference between the Aid flow (current US$) of European Union and Aid flow (current US$) of Iceland?
Offer a very short reply. 8.64e+06. In the year 1975, what is the difference between the Aid flow (current US$) of United Kingdom and Aid flow (current US$) of United States?
Your answer should be very brief. 4.53e+06. In the year 1975, what is the difference between the Aid flow (current US$) of United Kingdom and Aid flow (current US$) of Iceland?
Make the answer very short. 3.20e+07. In the year 1975, what is the difference between the Aid flow (current US$) of United States and Aid flow (current US$) of Iceland?
Your answer should be compact. 2.74e+07. What is the ratio of the Aid flow (current US$) in European Union in 1968 to that in 1969?
Provide a succinct answer. 1.04. What is the ratio of the Aid flow (current US$) in United Kingdom in 1968 to that in 1969?
Your response must be concise. 1.23. What is the ratio of the Aid flow (current US$) in United States in 1968 to that in 1969?
Your answer should be compact. 0.69. What is the ratio of the Aid flow (current US$) of Iceland in 1968 to that in 1969?
Keep it short and to the point. 0.79. What is the ratio of the Aid flow (current US$) of European Union in 1968 to that in 1970?
Your response must be concise. 0.66. What is the ratio of the Aid flow (current US$) in United Kingdom in 1968 to that in 1970?
Offer a very short reply. 2.25. What is the ratio of the Aid flow (current US$) in Iceland in 1968 to that in 1970?
Ensure brevity in your answer.  0.74. What is the ratio of the Aid flow (current US$) of European Union in 1968 to that in 1971?
Your answer should be compact. 0.62. What is the ratio of the Aid flow (current US$) of United Kingdom in 1968 to that in 1971?
Your response must be concise. 1.49. What is the ratio of the Aid flow (current US$) in Iceland in 1968 to that in 1971?
Keep it short and to the point. 0.49. What is the ratio of the Aid flow (current US$) of European Union in 1968 to that in 1972?
Ensure brevity in your answer.  0.52. What is the ratio of the Aid flow (current US$) in United Kingdom in 1968 to that in 1972?
Keep it short and to the point. 1.51. What is the ratio of the Aid flow (current US$) in Iceland in 1968 to that in 1972?
Make the answer very short. 0.64. What is the ratio of the Aid flow (current US$) in European Union in 1968 to that in 1973?
Give a very brief answer. 0.3. What is the ratio of the Aid flow (current US$) of United Kingdom in 1968 to that in 1973?
Your answer should be compact. 1.64. What is the ratio of the Aid flow (current US$) in United States in 1968 to that in 1973?
Make the answer very short. 0.56. What is the ratio of the Aid flow (current US$) of Iceland in 1968 to that in 1973?
Keep it short and to the point. 0.34. What is the ratio of the Aid flow (current US$) of European Union in 1968 to that in 1974?
Give a very brief answer. 0.75. What is the ratio of the Aid flow (current US$) in United Kingdom in 1968 to that in 1974?
Offer a terse response. 1.25. What is the ratio of the Aid flow (current US$) of Iceland in 1968 to that in 1974?
Your answer should be very brief. 0.3. What is the ratio of the Aid flow (current US$) in European Union in 1968 to that in 1975?
Your answer should be compact. 0.46. What is the ratio of the Aid flow (current US$) in United Kingdom in 1968 to that in 1975?
Offer a very short reply. 1.32. What is the ratio of the Aid flow (current US$) in United States in 1968 to that in 1975?
Make the answer very short. 0.3. What is the ratio of the Aid flow (current US$) of Iceland in 1968 to that in 1975?
Give a very brief answer. 0.39. What is the ratio of the Aid flow (current US$) in European Union in 1969 to that in 1970?
Provide a succinct answer. 0.63. What is the ratio of the Aid flow (current US$) of United Kingdom in 1969 to that in 1970?
Make the answer very short. 1.82. What is the ratio of the Aid flow (current US$) of United States in 1969 to that in 1970?
Offer a terse response. 1.08. What is the ratio of the Aid flow (current US$) of Iceland in 1969 to that in 1970?
Give a very brief answer. 0.93. What is the ratio of the Aid flow (current US$) in European Union in 1969 to that in 1971?
Give a very brief answer. 0.59. What is the ratio of the Aid flow (current US$) of United Kingdom in 1969 to that in 1971?
Give a very brief answer. 1.21. What is the ratio of the Aid flow (current US$) of Iceland in 1969 to that in 1971?
Offer a very short reply. 0.63. What is the ratio of the Aid flow (current US$) in European Union in 1969 to that in 1972?
Offer a terse response. 0.5. What is the ratio of the Aid flow (current US$) in United Kingdom in 1969 to that in 1972?
Offer a terse response. 1.23. What is the ratio of the Aid flow (current US$) of United States in 1969 to that in 1972?
Offer a very short reply. 1.44. What is the ratio of the Aid flow (current US$) in Iceland in 1969 to that in 1972?
Offer a very short reply. 0.81. What is the ratio of the Aid flow (current US$) in European Union in 1969 to that in 1973?
Ensure brevity in your answer.  0.28. What is the ratio of the Aid flow (current US$) of United Kingdom in 1969 to that in 1973?
Your response must be concise. 1.33. What is the ratio of the Aid flow (current US$) of United States in 1969 to that in 1973?
Provide a succinct answer. 0.81. What is the ratio of the Aid flow (current US$) of Iceland in 1969 to that in 1973?
Provide a succinct answer. 0.43. What is the ratio of the Aid flow (current US$) in European Union in 1969 to that in 1974?
Ensure brevity in your answer.  0.72. What is the ratio of the Aid flow (current US$) in United Kingdom in 1969 to that in 1974?
Provide a succinct answer. 1.01. What is the ratio of the Aid flow (current US$) of United States in 1969 to that in 1974?
Your response must be concise. 0.87. What is the ratio of the Aid flow (current US$) in Iceland in 1969 to that in 1974?
Make the answer very short. 0.38. What is the ratio of the Aid flow (current US$) in European Union in 1969 to that in 1975?
Make the answer very short. 0.44. What is the ratio of the Aid flow (current US$) in United Kingdom in 1969 to that in 1975?
Provide a succinct answer. 1.07. What is the ratio of the Aid flow (current US$) of United States in 1969 to that in 1975?
Offer a terse response. 0.43. What is the ratio of the Aid flow (current US$) in Iceland in 1969 to that in 1975?
Your response must be concise. 0.49. What is the ratio of the Aid flow (current US$) in European Union in 1970 to that in 1971?
Provide a succinct answer. 0.94. What is the ratio of the Aid flow (current US$) in United Kingdom in 1970 to that in 1971?
Your answer should be compact. 0.66. What is the ratio of the Aid flow (current US$) in United States in 1970 to that in 1971?
Your answer should be very brief. 1. What is the ratio of the Aid flow (current US$) of Iceland in 1970 to that in 1971?
Your response must be concise. 0.67. What is the ratio of the Aid flow (current US$) of European Union in 1970 to that in 1972?
Your answer should be very brief. 0.79. What is the ratio of the Aid flow (current US$) of United Kingdom in 1970 to that in 1972?
Your answer should be compact. 0.67. What is the ratio of the Aid flow (current US$) of United States in 1970 to that in 1972?
Ensure brevity in your answer.  1.33. What is the ratio of the Aid flow (current US$) in Iceland in 1970 to that in 1972?
Keep it short and to the point. 0.87. What is the ratio of the Aid flow (current US$) in European Union in 1970 to that in 1973?
Make the answer very short. 0.45. What is the ratio of the Aid flow (current US$) of United Kingdom in 1970 to that in 1973?
Offer a very short reply. 0.73. What is the ratio of the Aid flow (current US$) in Iceland in 1970 to that in 1973?
Keep it short and to the point. 0.46. What is the ratio of the Aid flow (current US$) of European Union in 1970 to that in 1974?
Offer a terse response. 1.14. What is the ratio of the Aid flow (current US$) in United Kingdom in 1970 to that in 1974?
Provide a short and direct response. 0.55. What is the ratio of the Aid flow (current US$) of United States in 1970 to that in 1974?
Provide a short and direct response. 0.8. What is the ratio of the Aid flow (current US$) of Iceland in 1970 to that in 1974?
Your answer should be very brief. 0.41. What is the ratio of the Aid flow (current US$) in European Union in 1970 to that in 1975?
Your response must be concise. 0.7. What is the ratio of the Aid flow (current US$) in United Kingdom in 1970 to that in 1975?
Your answer should be very brief. 0.59. What is the ratio of the Aid flow (current US$) of United States in 1970 to that in 1975?
Offer a terse response. 0.4. What is the ratio of the Aid flow (current US$) of Iceland in 1970 to that in 1975?
Ensure brevity in your answer.  0.53. What is the ratio of the Aid flow (current US$) of European Union in 1971 to that in 1972?
Keep it short and to the point. 0.84. What is the ratio of the Aid flow (current US$) in United Kingdom in 1971 to that in 1972?
Provide a short and direct response. 1.02. What is the ratio of the Aid flow (current US$) in Iceland in 1971 to that in 1972?
Provide a succinct answer. 1.29. What is the ratio of the Aid flow (current US$) of European Union in 1971 to that in 1973?
Give a very brief answer. 0.48. What is the ratio of the Aid flow (current US$) of United Kingdom in 1971 to that in 1973?
Provide a succinct answer. 1.1. What is the ratio of the Aid flow (current US$) in Iceland in 1971 to that in 1973?
Your answer should be compact. 0.68. What is the ratio of the Aid flow (current US$) of European Union in 1971 to that in 1974?
Your answer should be very brief. 1.21. What is the ratio of the Aid flow (current US$) in United Kingdom in 1971 to that in 1974?
Provide a short and direct response. 0.84. What is the ratio of the Aid flow (current US$) in United States in 1971 to that in 1974?
Your answer should be very brief. 0.8. What is the ratio of the Aid flow (current US$) of Iceland in 1971 to that in 1974?
Offer a very short reply. 0.6. What is the ratio of the Aid flow (current US$) in European Union in 1971 to that in 1975?
Ensure brevity in your answer.  0.75. What is the ratio of the Aid flow (current US$) in United Kingdom in 1971 to that in 1975?
Provide a succinct answer. 0.89. What is the ratio of the Aid flow (current US$) of United States in 1971 to that in 1975?
Ensure brevity in your answer.  0.4. What is the ratio of the Aid flow (current US$) in Iceland in 1971 to that in 1975?
Provide a succinct answer. 0.79. What is the ratio of the Aid flow (current US$) of European Union in 1972 to that in 1973?
Keep it short and to the point. 0.57. What is the ratio of the Aid flow (current US$) of United Kingdom in 1972 to that in 1973?
Provide a short and direct response. 1.08. What is the ratio of the Aid flow (current US$) in United States in 1972 to that in 1973?
Give a very brief answer. 0.56. What is the ratio of the Aid flow (current US$) in Iceland in 1972 to that in 1973?
Your response must be concise. 0.52. What is the ratio of the Aid flow (current US$) of European Union in 1972 to that in 1974?
Offer a terse response. 1.45. What is the ratio of the Aid flow (current US$) in United Kingdom in 1972 to that in 1974?
Offer a very short reply. 0.82. What is the ratio of the Aid flow (current US$) of Iceland in 1972 to that in 1974?
Provide a short and direct response. 0.47. What is the ratio of the Aid flow (current US$) of European Union in 1972 to that in 1975?
Offer a very short reply. 0.89. What is the ratio of the Aid flow (current US$) in United Kingdom in 1972 to that in 1975?
Your answer should be compact. 0.87. What is the ratio of the Aid flow (current US$) of Iceland in 1972 to that in 1975?
Offer a very short reply. 0.61. What is the ratio of the Aid flow (current US$) in European Union in 1973 to that in 1974?
Give a very brief answer. 2.52. What is the ratio of the Aid flow (current US$) in United Kingdom in 1973 to that in 1974?
Offer a terse response. 0.76. What is the ratio of the Aid flow (current US$) of United States in 1973 to that in 1974?
Keep it short and to the point. 1.07. What is the ratio of the Aid flow (current US$) in Iceland in 1973 to that in 1974?
Your answer should be compact. 0.89. What is the ratio of the Aid flow (current US$) in European Union in 1973 to that in 1975?
Your answer should be compact. 1.56. What is the ratio of the Aid flow (current US$) of United Kingdom in 1973 to that in 1975?
Provide a short and direct response. 0.81. What is the ratio of the Aid flow (current US$) of United States in 1973 to that in 1975?
Give a very brief answer. 0.53. What is the ratio of the Aid flow (current US$) in Iceland in 1973 to that in 1975?
Your answer should be compact. 1.16. What is the ratio of the Aid flow (current US$) of European Union in 1974 to that in 1975?
Keep it short and to the point. 0.62. What is the ratio of the Aid flow (current US$) of United Kingdom in 1974 to that in 1975?
Your response must be concise. 1.06. What is the ratio of the Aid flow (current US$) of United States in 1974 to that in 1975?
Your answer should be compact. 0.5. What is the ratio of the Aid flow (current US$) of Iceland in 1974 to that in 1975?
Provide a succinct answer. 1.3. What is the difference between the highest and the second highest Aid flow (current US$) of European Union?
Provide a succinct answer. 6.24e+06. What is the difference between the highest and the second highest Aid flow (current US$) in United Kingdom?
Offer a very short reply. 8.65e+06. What is the difference between the highest and the second highest Aid flow (current US$) of United States?
Provide a short and direct response. 1.40e+07. What is the difference between the highest and the lowest Aid flow (current US$) of European Union?
Your answer should be very brief. 1.25e+07. What is the difference between the highest and the lowest Aid flow (current US$) in United Kingdom?
Keep it short and to the point. 2.54e+07. What is the difference between the highest and the lowest Aid flow (current US$) in United States?
Make the answer very short. 2.10e+07. What is the difference between the highest and the lowest Aid flow (current US$) in Iceland?
Offer a very short reply. 2.34e+06. 